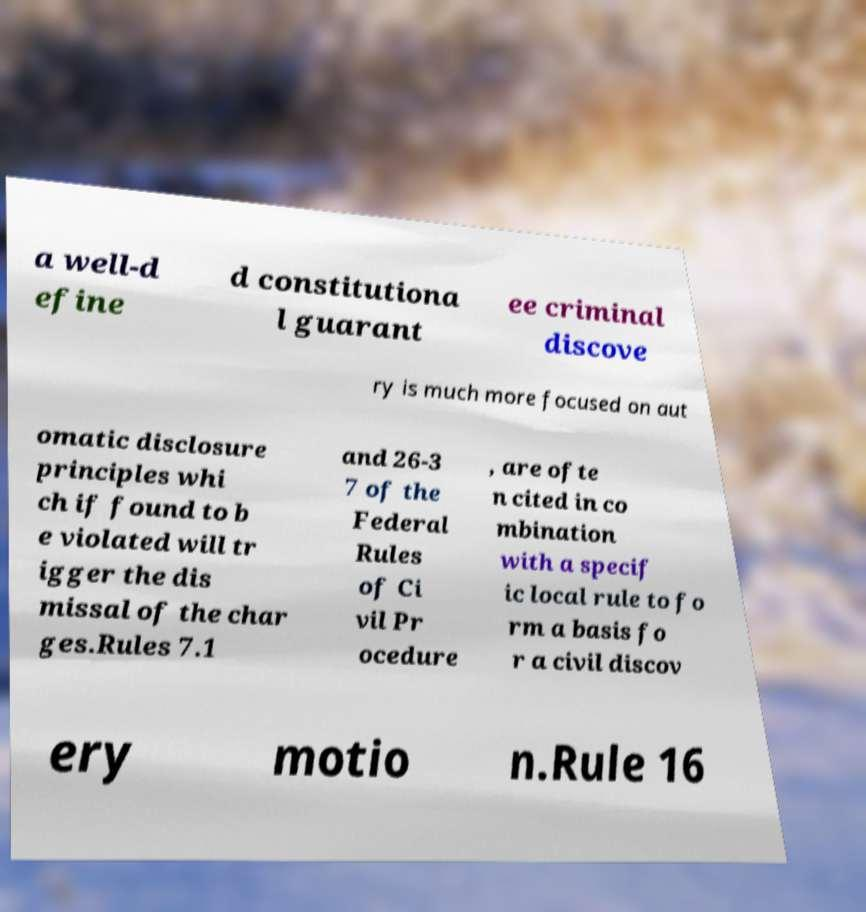Could you assist in decoding the text presented in this image and type it out clearly? a well-d efine d constitutiona l guarant ee criminal discove ry is much more focused on aut omatic disclosure principles whi ch if found to b e violated will tr igger the dis missal of the char ges.Rules 7.1 and 26-3 7 of the Federal Rules of Ci vil Pr ocedure , are ofte n cited in co mbination with a specif ic local rule to fo rm a basis fo r a civil discov ery motio n.Rule 16 